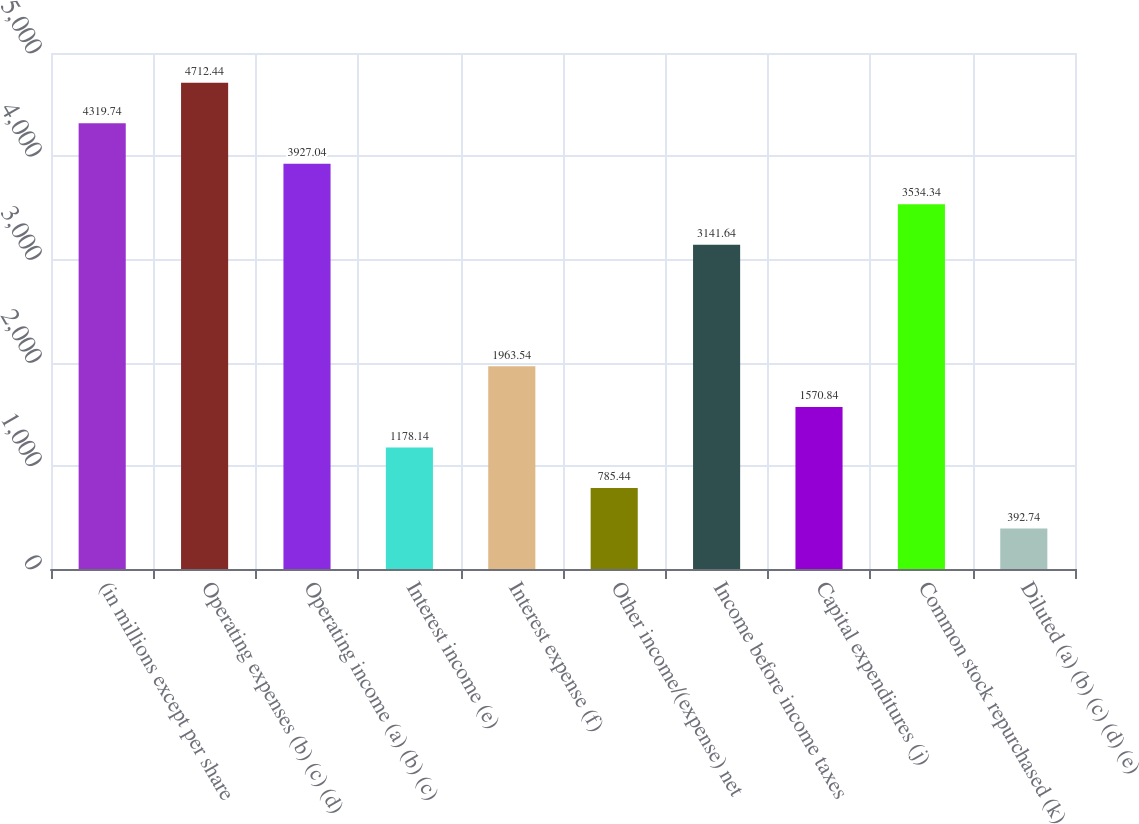<chart> <loc_0><loc_0><loc_500><loc_500><bar_chart><fcel>(in millions except per share<fcel>Operating expenses (b) (c) (d)<fcel>Operating income (a) (b) (c)<fcel>Interest income (e)<fcel>Interest expense (f)<fcel>Other income/(expense) net<fcel>Income before income taxes<fcel>Capital expenditures (j)<fcel>Common stock repurchased (k)<fcel>Diluted (a) (b) (c) (d) (e)<nl><fcel>4319.74<fcel>4712.44<fcel>3927.04<fcel>1178.14<fcel>1963.54<fcel>785.44<fcel>3141.64<fcel>1570.84<fcel>3534.34<fcel>392.74<nl></chart> 